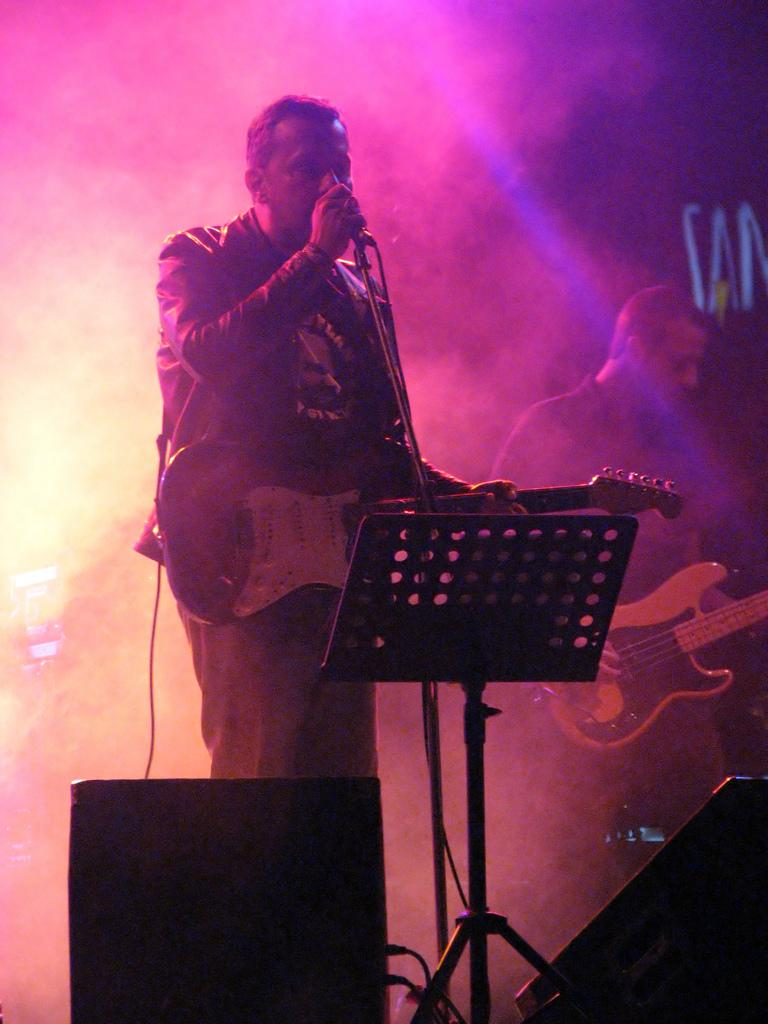What is the man in the image holding? The man is holding a microphone in the image. What is the other man in the image holding? The other man is holding a guitar in the image. What object is located in the front of the image? There is a sound box in the front of the image. What can be seen in the image that is not a person or an instrument? There is smoke visible in the image. Where is the deer located in the image? There is no deer present in the image. What impulse might the man holding the microphone be feeling? We cannot determine the man's emotions or impulses from the image alone. 